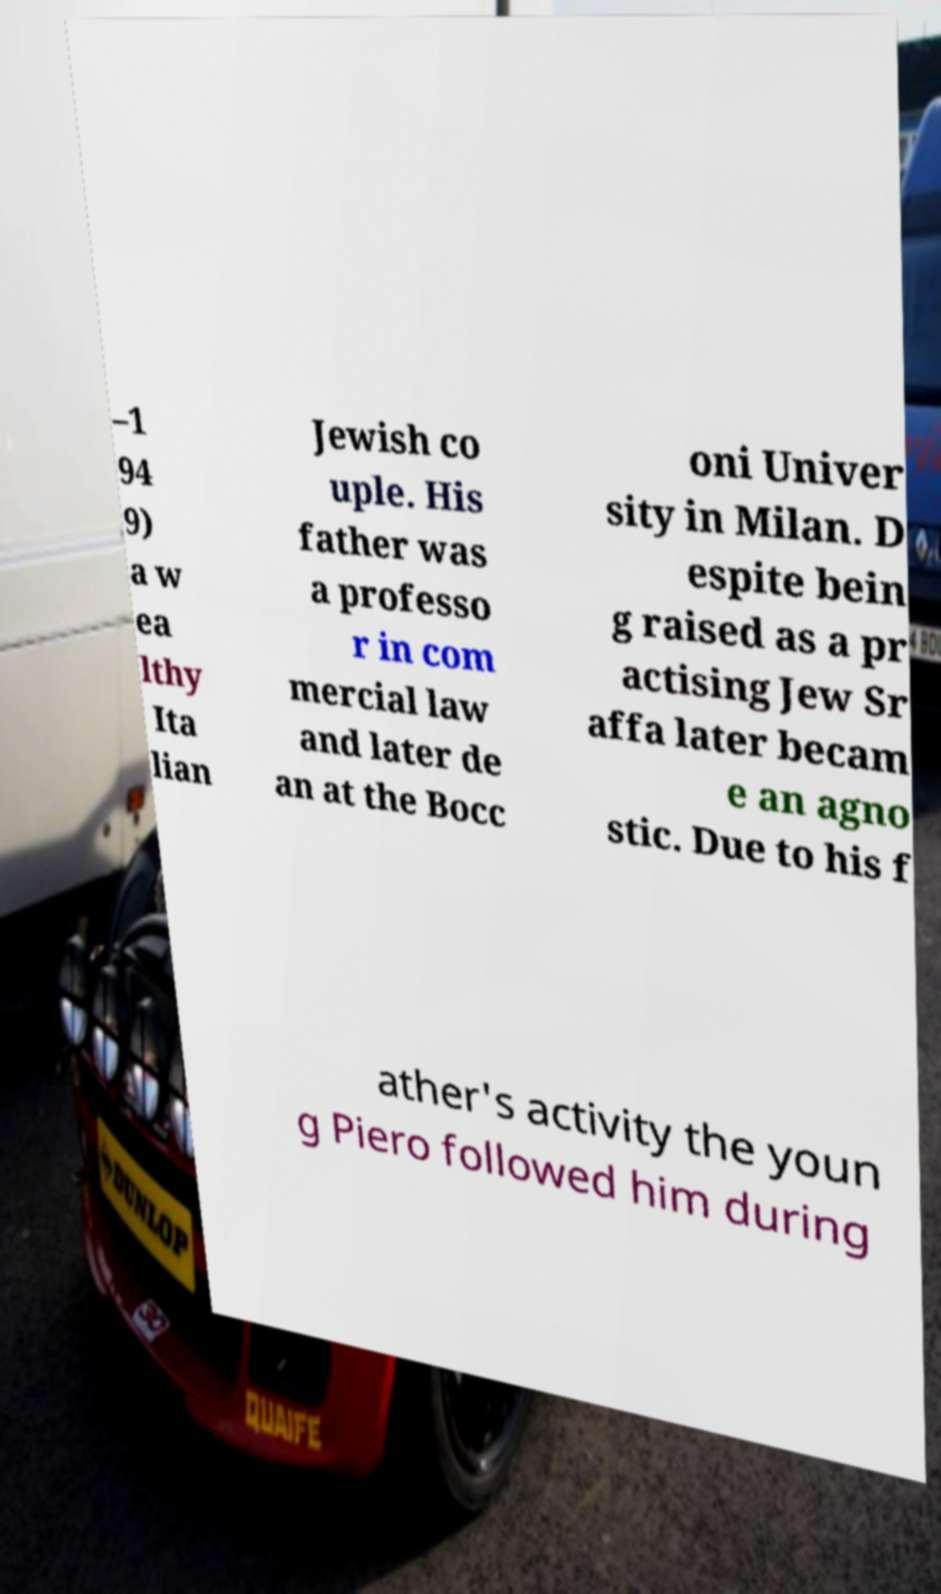Can you accurately transcribe the text from the provided image for me? –1 94 9) a w ea lthy Ita lian Jewish co uple. His father was a professo r in com mercial law and later de an at the Bocc oni Univer sity in Milan. D espite bein g raised as a pr actising Jew Sr affa later becam e an agno stic. Due to his f ather's activity the youn g Piero followed him during 